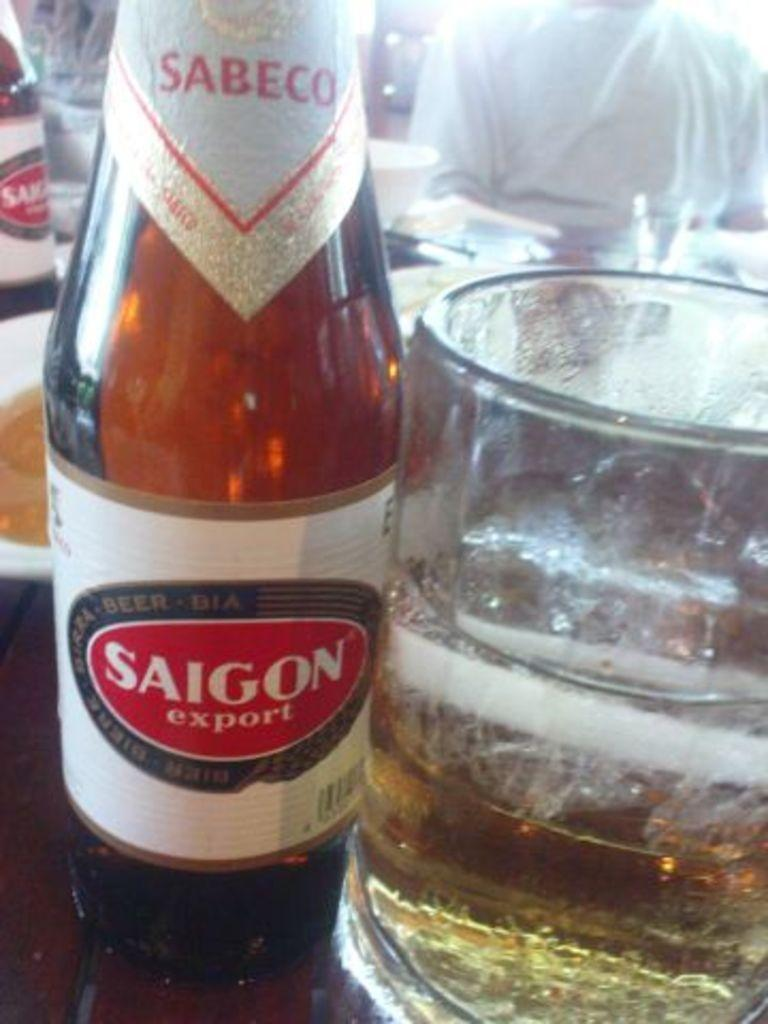Provide a one-sentence caption for the provided image. A glass of beer next to a bottle reading Saigon Export. 